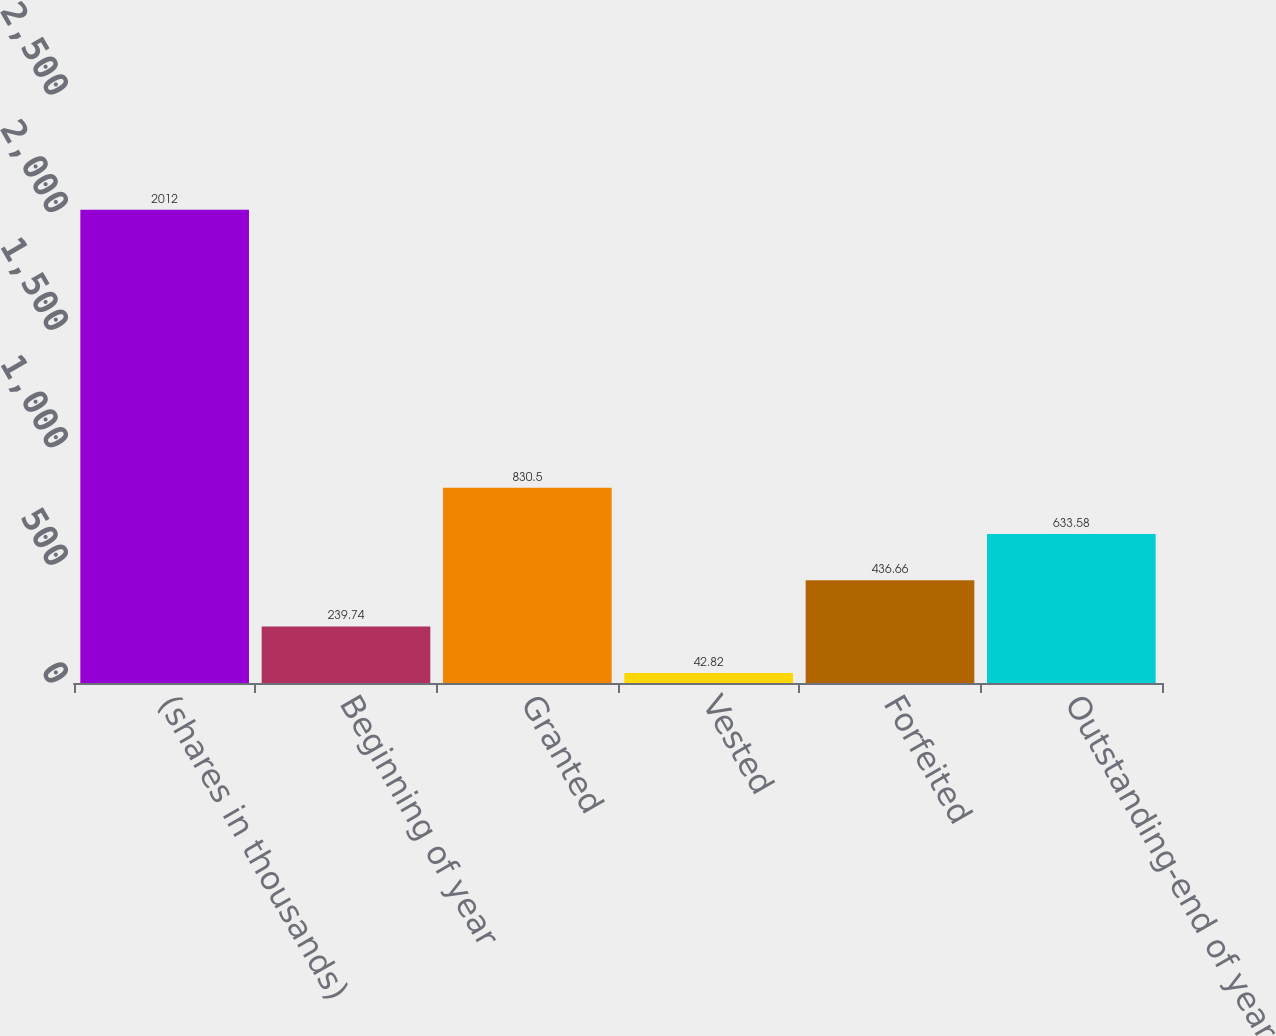Convert chart to OTSL. <chart><loc_0><loc_0><loc_500><loc_500><bar_chart><fcel>(shares in thousands)<fcel>Beginning of year<fcel>Granted<fcel>Vested<fcel>Forfeited<fcel>Outstanding-end of year<nl><fcel>2012<fcel>239.74<fcel>830.5<fcel>42.82<fcel>436.66<fcel>633.58<nl></chart> 